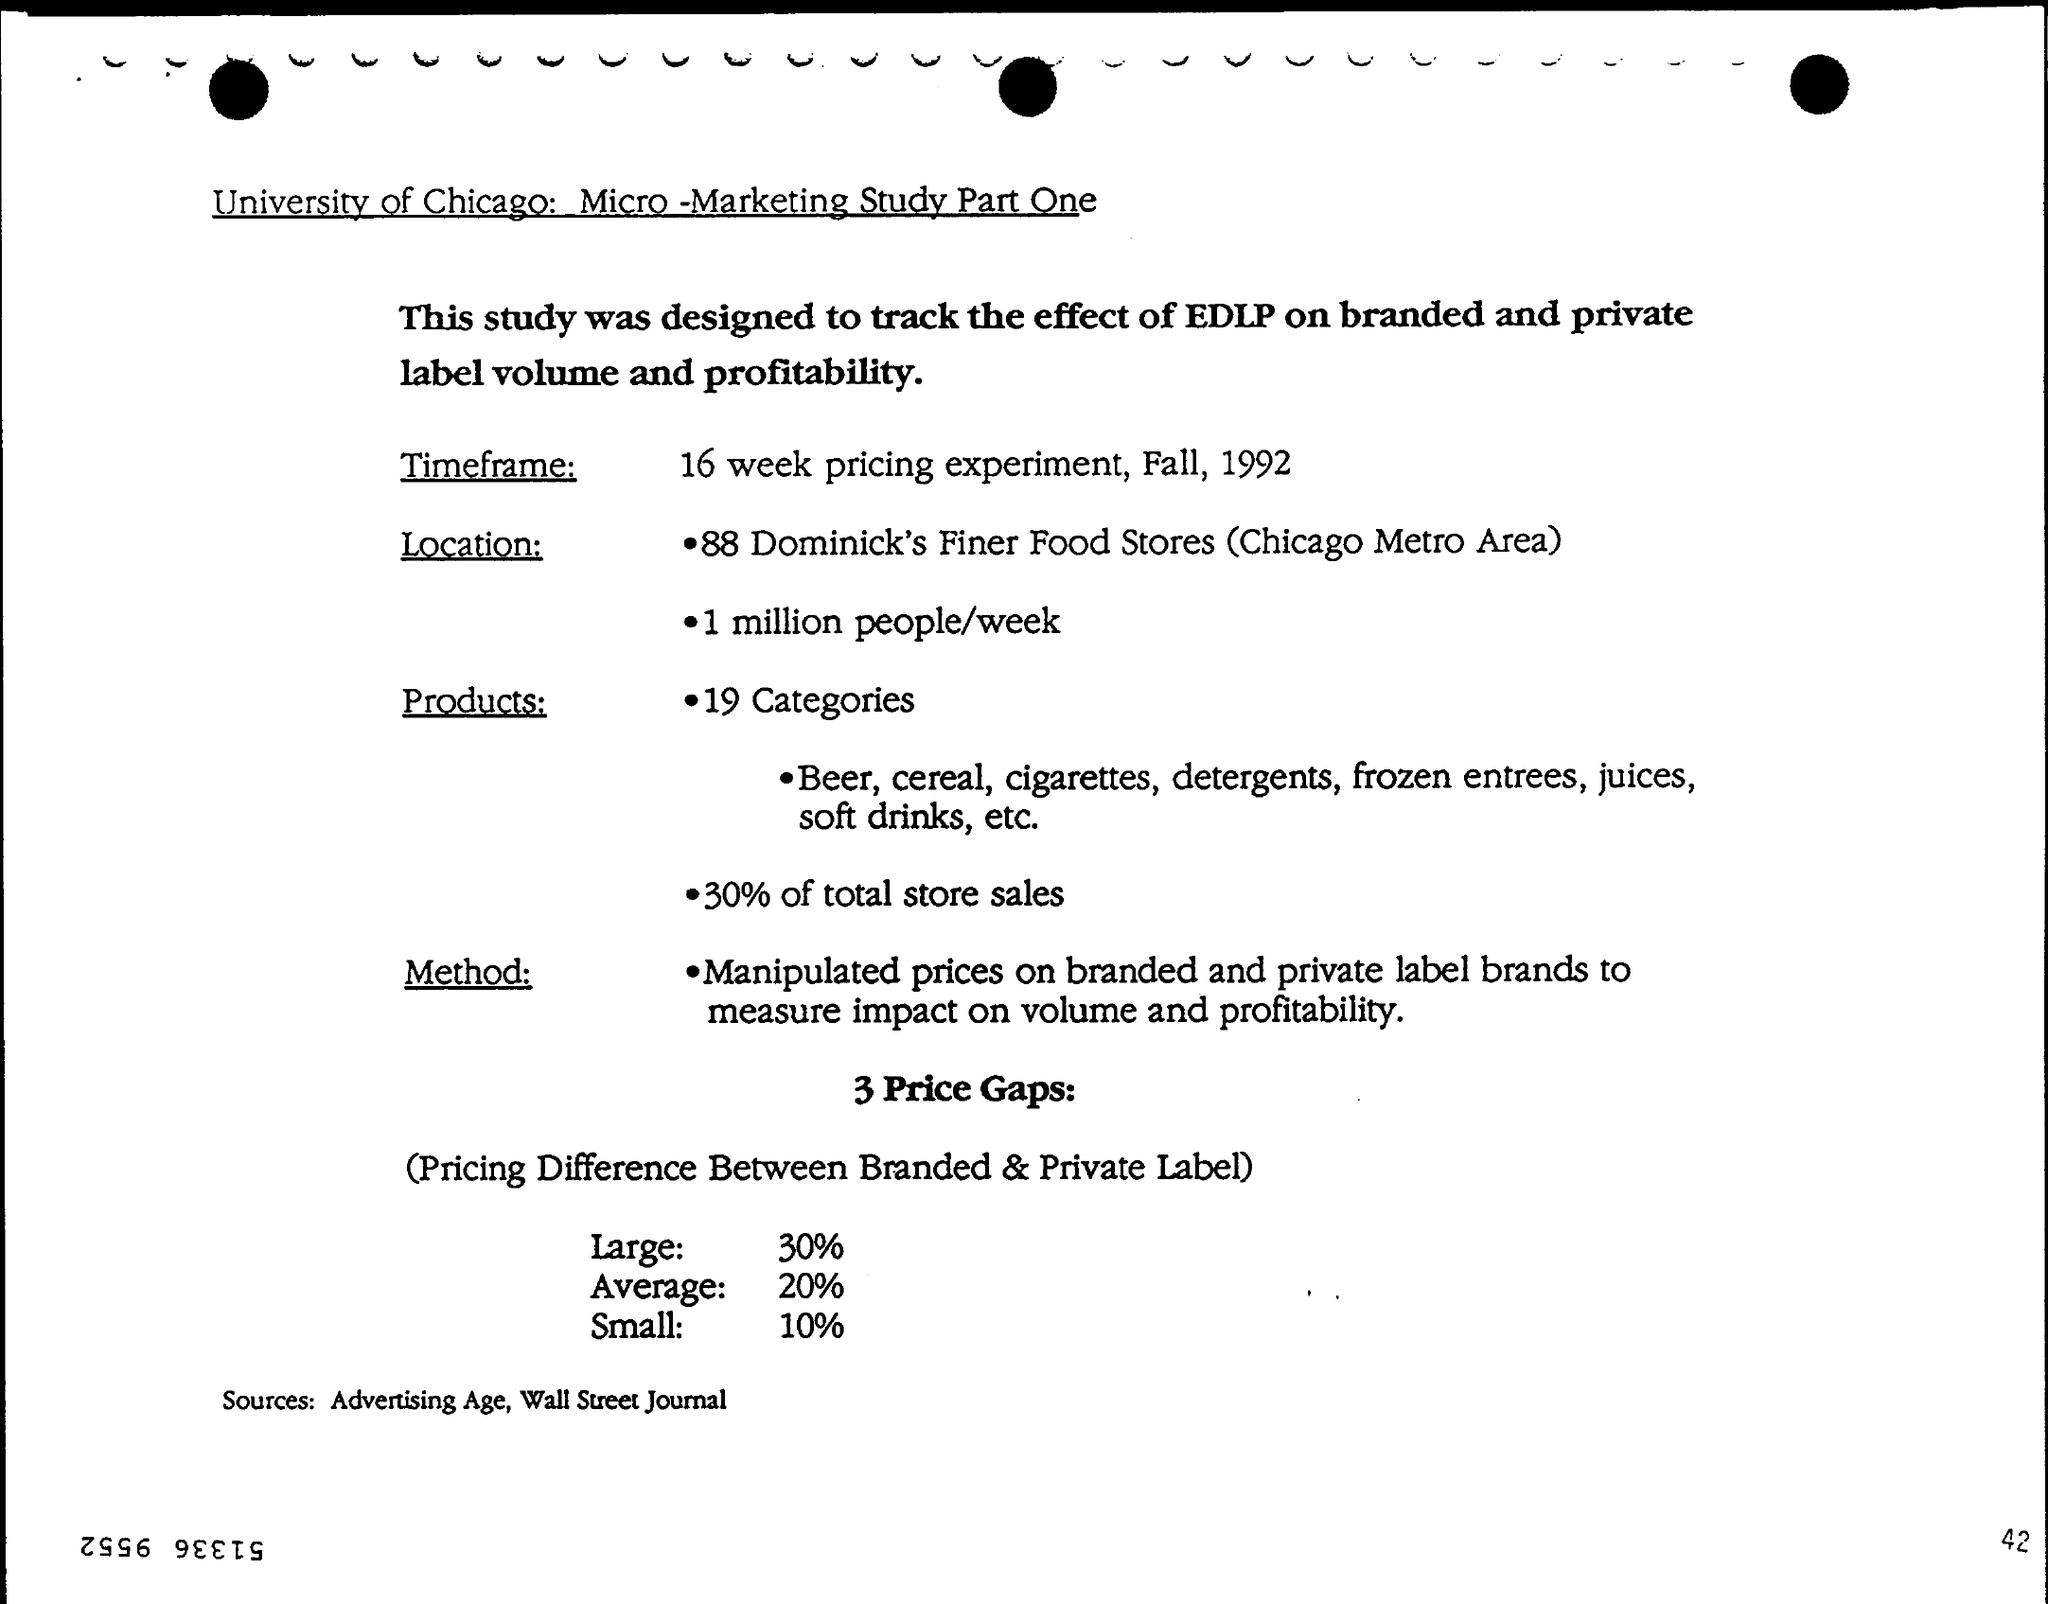Identify some key points in this picture. The document in question is titled "University of Chicago: Micro-Marketing Study Part One. The page number is 42. 